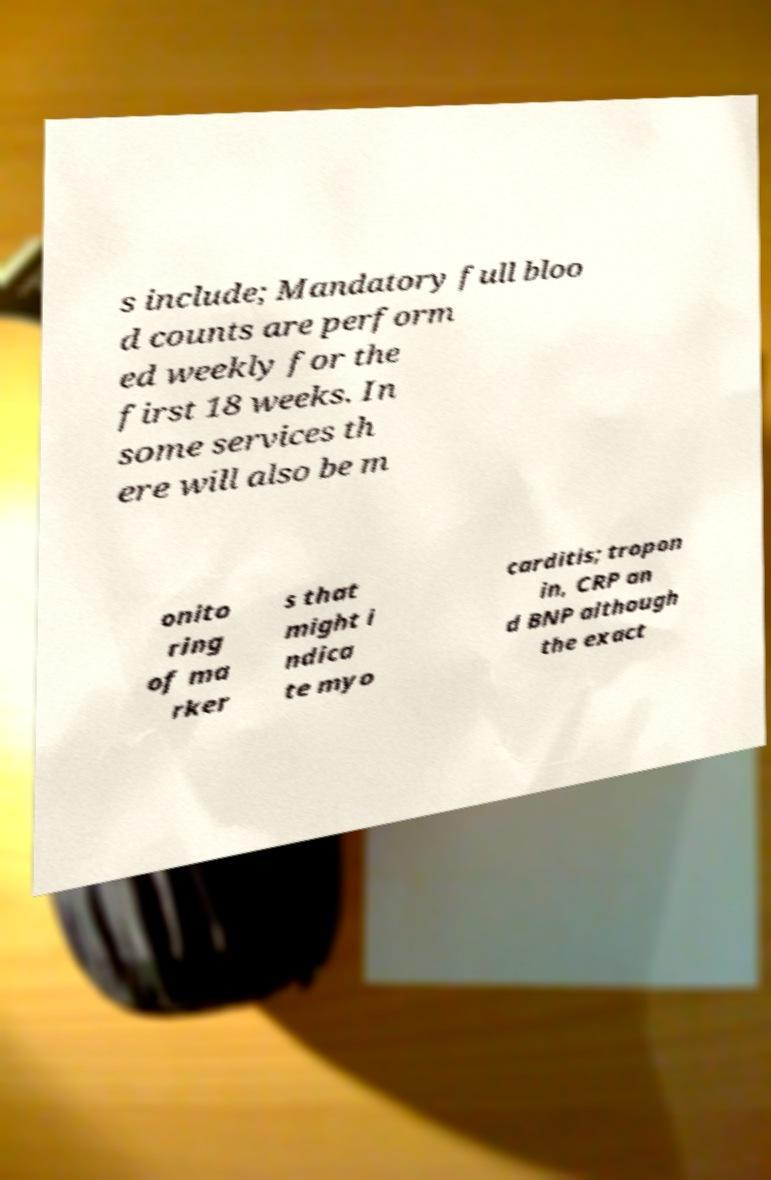Please read and relay the text visible in this image. What does it say? s include; Mandatory full bloo d counts are perform ed weekly for the first 18 weeks. In some services th ere will also be m onito ring of ma rker s that might i ndica te myo carditis; tropon in, CRP an d BNP although the exact 